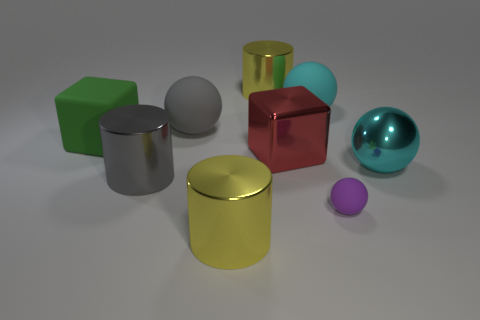Add 1 large red cubes. How many objects exist? 10 Subtract all cylinders. How many objects are left? 6 Subtract all cyan rubber balls. Subtract all big gray metallic objects. How many objects are left? 7 Add 3 red cubes. How many red cubes are left? 4 Add 4 large cyan things. How many large cyan things exist? 6 Subtract 1 purple spheres. How many objects are left? 8 